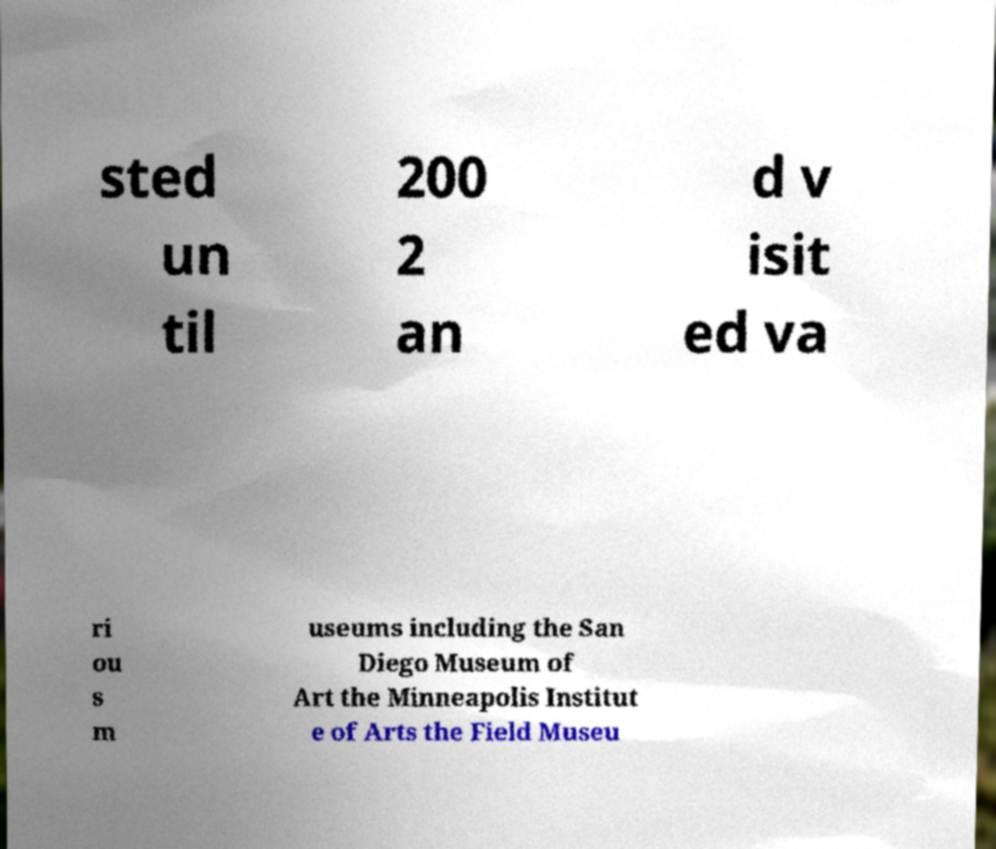Could you assist in decoding the text presented in this image and type it out clearly? sted un til 200 2 an d v isit ed va ri ou s m useums including the San Diego Museum of Art the Minneapolis Institut e of Arts the Field Museu 